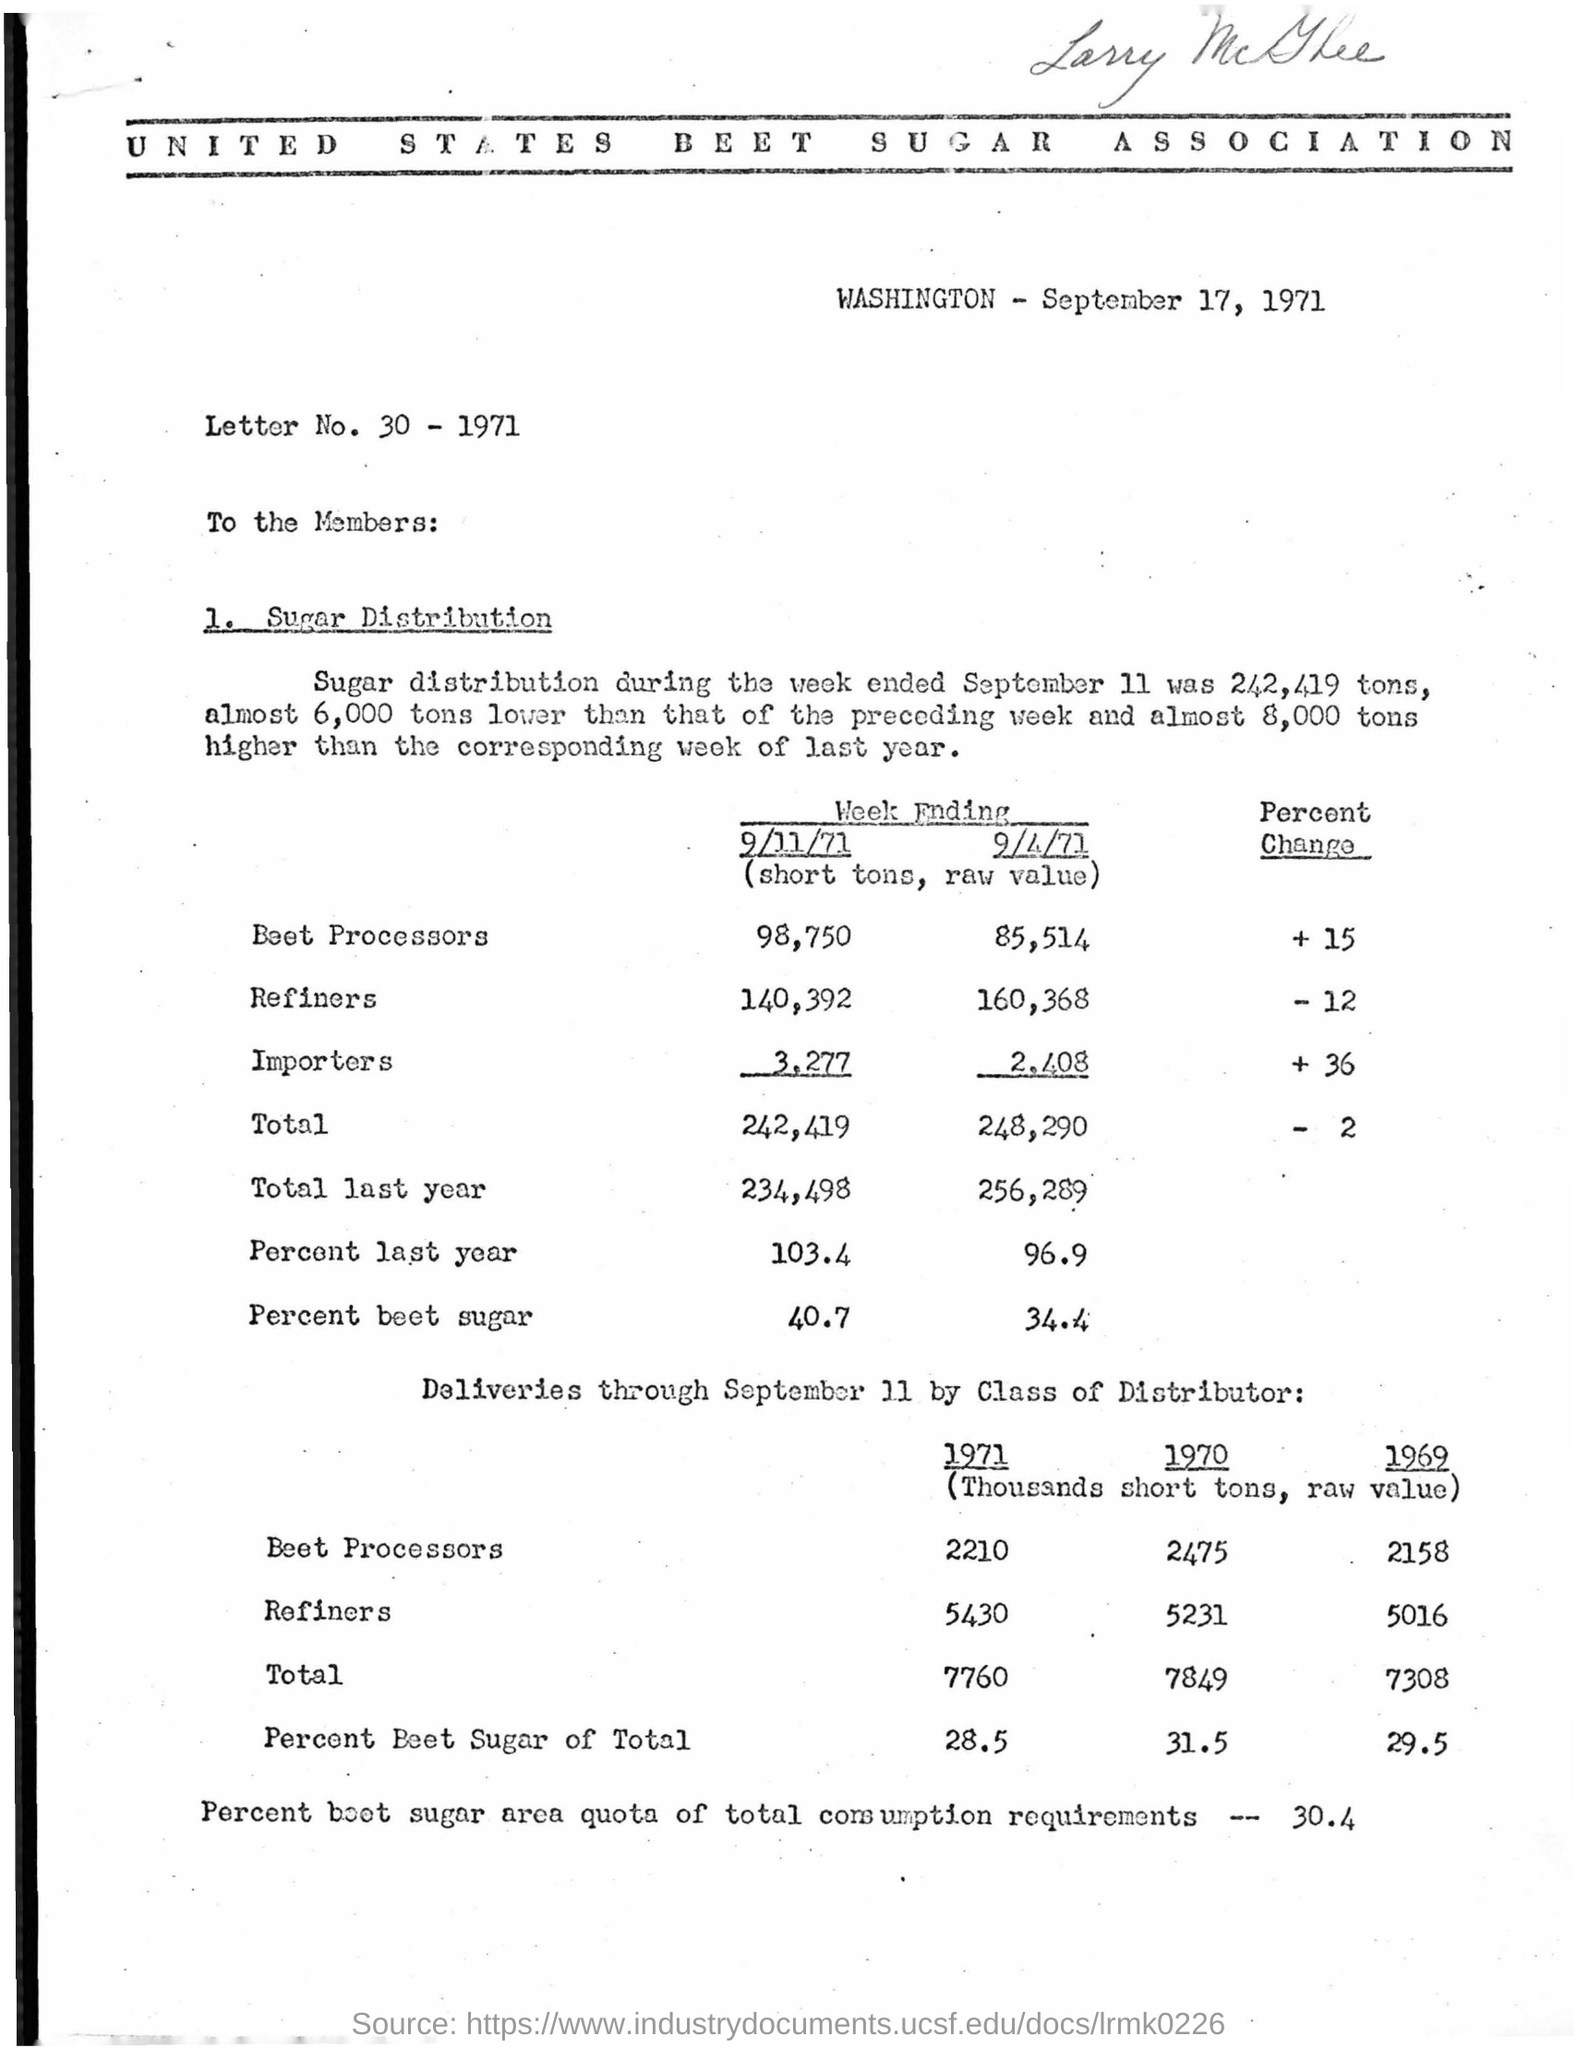What is the letter number?
Offer a terse response. 30 - 1971. What is the issued date of the letter?
Offer a terse response. September 17, 1971. 